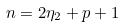Convert formula to latex. <formula><loc_0><loc_0><loc_500><loc_500>n = 2 \eta _ { 2 } + p + 1</formula> 